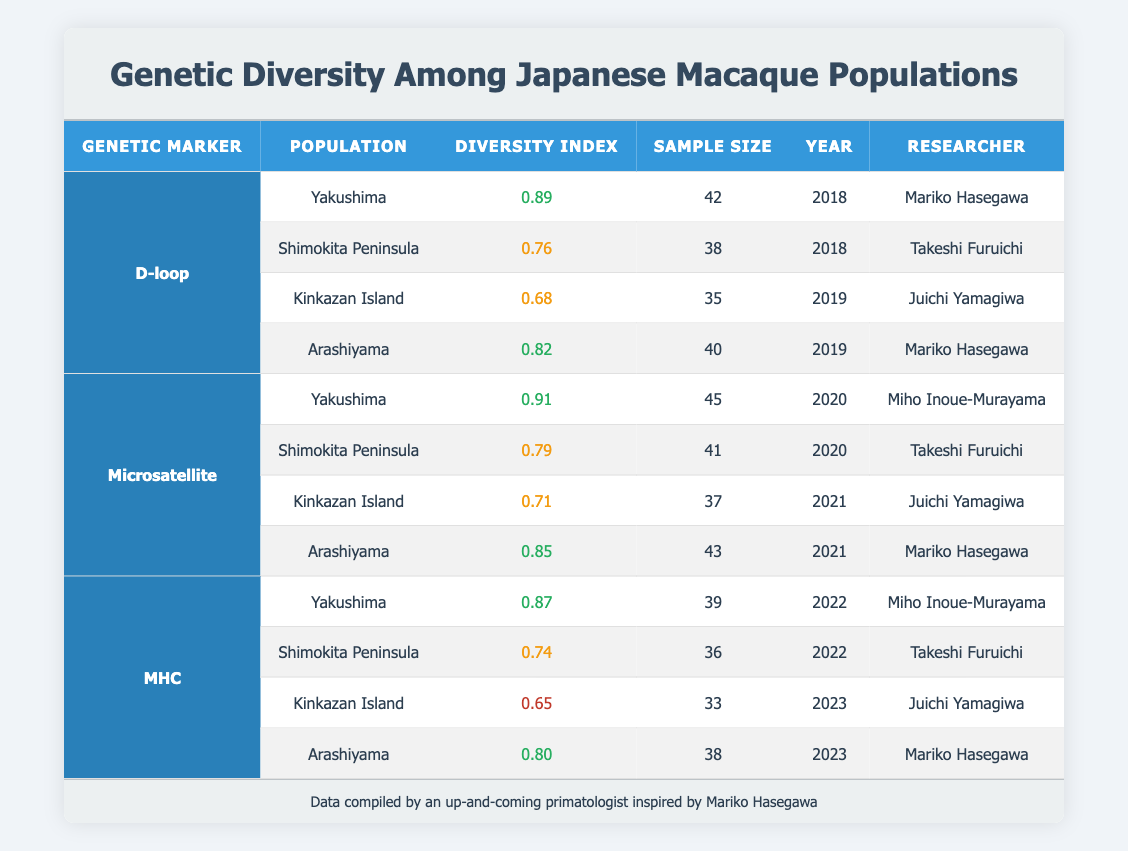What is the diversity index for the Yakushima population using the D-loop genetic marker? The table shows that for the D-loop genetic marker, the Yakushima population has a diversity index of 0.89 listed in the first row.
Answer: 0.89 What is the sample size of the Shimokita Peninsula for the Microsatellite genetic marker in 2020? According to the table, the Shimokita Peninsula has a sample size of 41 for the Microsatellite genetic marker in 2020, as seen in the second row of the Microsatellite section.
Answer: 41 Which population had the highest diversity index using the MHC genetic marker? The table indicates that for the MHC genetic marker, the Yakushima population had a diversity index of 0.87 in 2022, which is the highest when compared to the other populations for the same marker.
Answer: Yakushima What is the average diversity index for the Kinkazan Island across all genetic markers? For Kinkazan Island, the diversity indices shown are 0.68 (D-loop in 2019), 0.71 (Microsatellite in 2021), and 0.65 (MHC in 2023). The average is calculated as (0.68 + 0.71 + 0.65) / 3 = 0.68.
Answer: 0.68 Does Kinkazan Island have a higher diversity index in MHC than Shimokita Peninsula? Kinkazan Island has a diversity index of 0.65 for the MHC marker, while Shimokita Peninsula has a diversity index of 0.74 for the same marker. Since 0.65 is less than 0.74, the statement is false.
Answer: No Which researcher conducted the study for Arashiyama in 2021? The table specifies that Mariko Hasegawa conducted the research for Arashiyama in 2021, found in the row for Arashiyama under the Microsatellite genetic marker.
Answer: Mariko Hasegawa What is the trend in the diversity index for the Shimokita Peninsula from 2018 to 2022 for the D-loop and MHC markers? The diversity index for Shimokita Peninsula in 2018 for D-loop is 0.76, and for MHC in 2022 is 0.74. It shows a slight decline from 0.76 to 0.74 over the years. So, the trend is downward.
Answer: Downward Which population has the lowest diversity index across all genetic markers in the last reported year? Only looking at the last reported values for each population, Kinkazan Island has a diversity index of 0.65, which is lower than Arashiyama (0.80) for the same year. Thus, Kinkazan Island has the lowest index overall.
Answer: Kinkazan Island What are the diversity indices for Arashiyama across all years and genetic markers? The table indicates that for Arashiyama, the indices are 0.82 (D-loop in 2019), 0.85 (Microsatellite in 2021), and 0.80 (MHC in 2023). Compiling this provides a complete trend for Arashiyama.
Answer: 0.82, 0.85, 0.80 